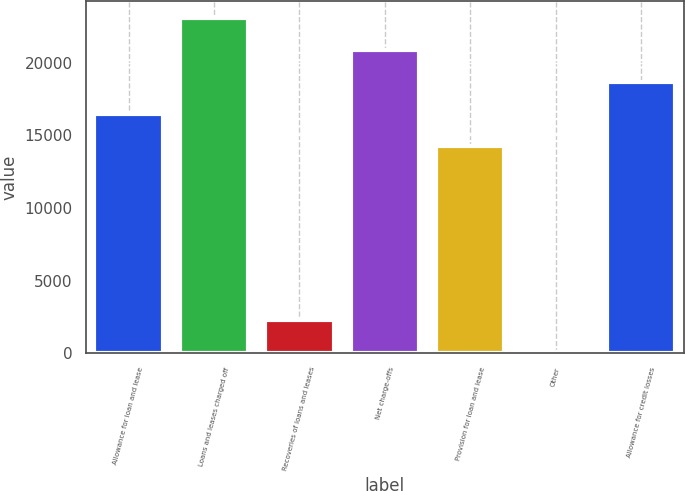<chart> <loc_0><loc_0><loc_500><loc_500><bar_chart><fcel>Allowance for loan and lease<fcel>Loans and leases charged off<fcel>Recoveries of loans and leases<fcel>Net charge-offs<fcel>Provision for loan and lease<fcel>Other<fcel>Allowance for credit losses<nl><fcel>16464.8<fcel>23118.5<fcel>2281.9<fcel>20900.6<fcel>14246.9<fcel>64<fcel>18682.7<nl></chart> 